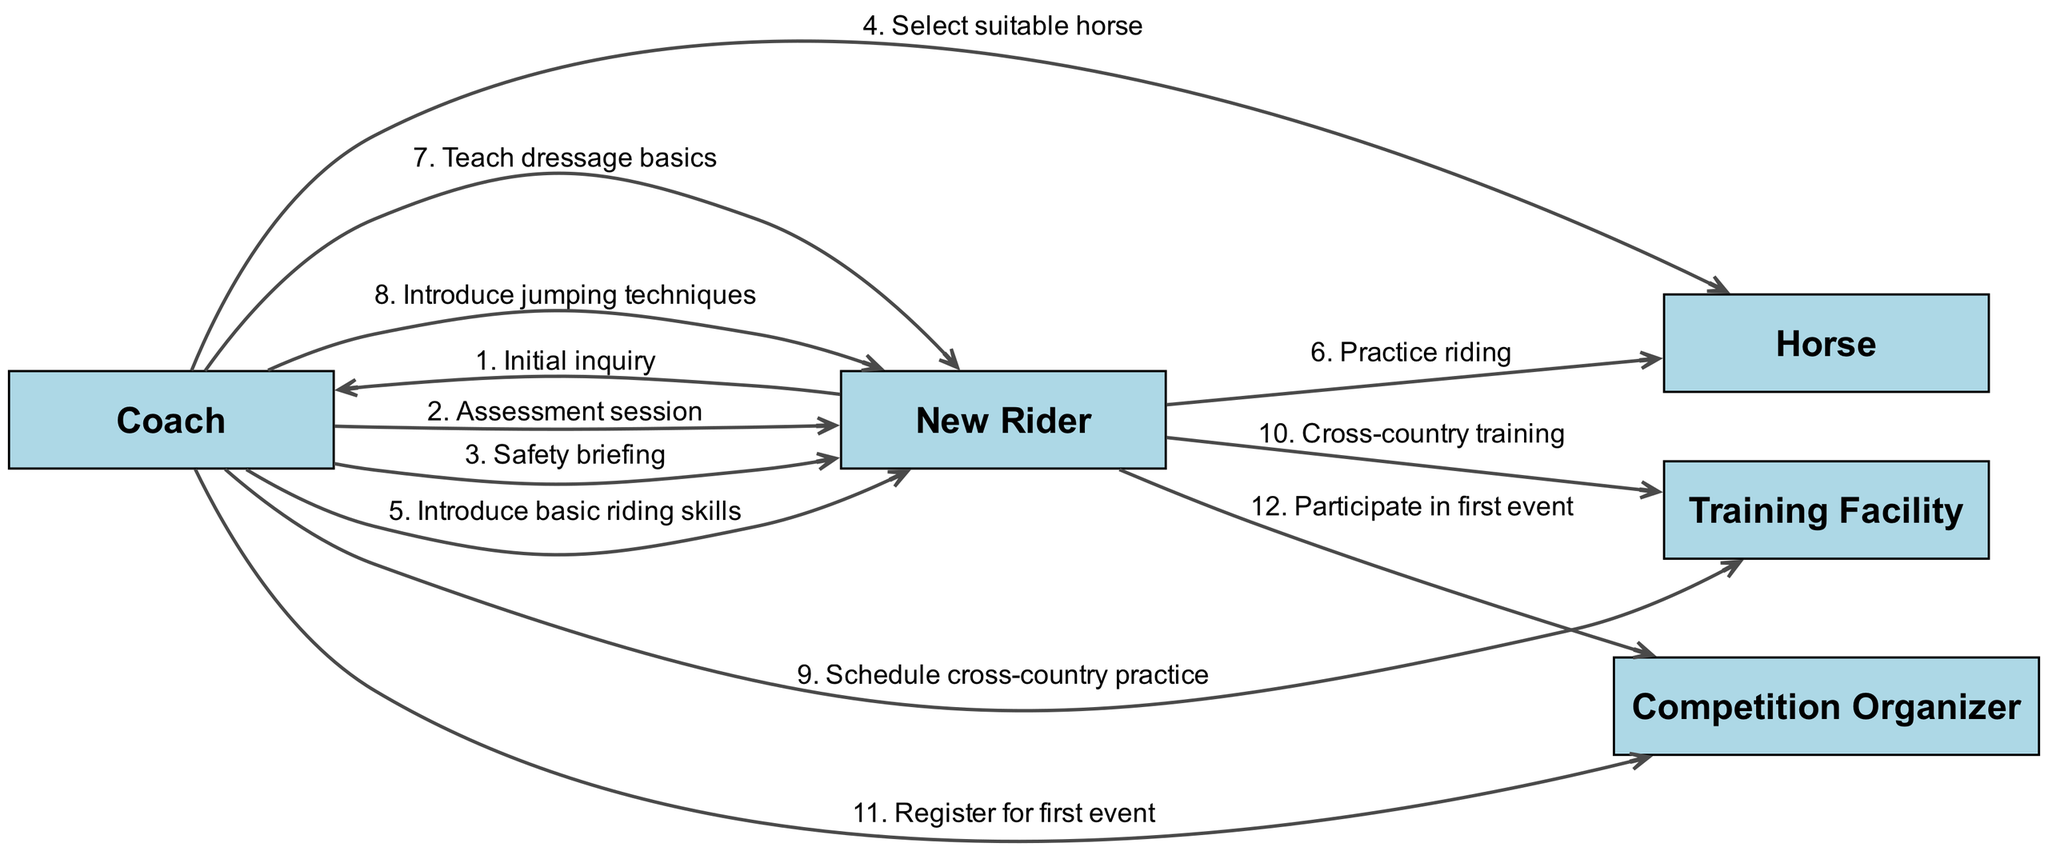What is the first message in the sequence? The first message is from the New Rider to the Coach, stating "Initial inquiry." This can be found at the beginning of the sequence flow.
Answer: Initial inquiry How many participants are involved in this training sequence? By counting the distinct entities listed as participants, we find there are five: Coach, New Rider, Horse, Training Facility, and Competition Organizer.
Answer: Five Which entity receives the message "Safety briefing"? The message "Safety briefing" is sent from the Coach to the New Rider, as indicated in the sequence steps.
Answer: New Rider What is the last step before participating in the first event? The last step before participating in the first event is the Coach registering for the first event, which happens just before the New Rider participates.
Answer: Register for first event How many messages are exchanged between the New Rider and the Horse? There are two messages exchanged: "Practice riding" from the New Rider to the Horse and another step involving the Horse related to training. Counting these gives a total of two messages.
Answer: Two Which message is related to modifying the rider's skills? The messages "Teach dressage basics" and "Introduce jumping techniques" relate to modifying the New Rider's skills. Both messages are sent from the Coach to the New Rider, emphasizing skill development.
Answer: Teach dressage basics, Introduce jumping techniques What role does the Training Facility play in the sequence? The Training Facility is involved in scheduling practices and hosting training sessions, particularly regarding cross-country training.
Answer: Schedule cross-country practice Which participant schedules the practices at the Training Facility? The Coach is the participant responsible for scheduling cross-country practice at the Training Facility, as specified in the sequence.
Answer: Coach 